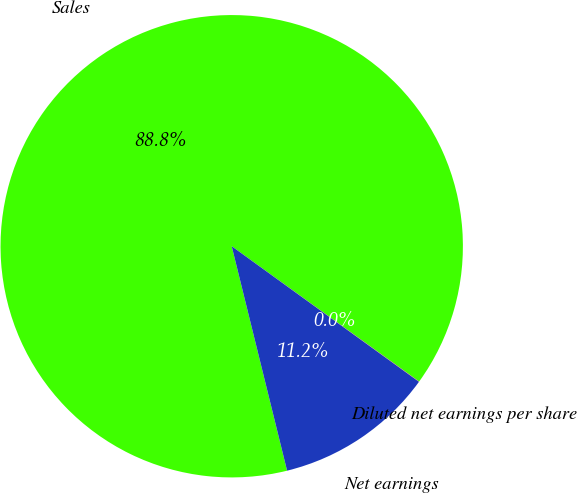<chart> <loc_0><loc_0><loc_500><loc_500><pie_chart><fcel>Sales<fcel>Net earnings<fcel>Diluted net earnings per share<nl><fcel>88.81%<fcel>11.18%<fcel>0.02%<nl></chart> 